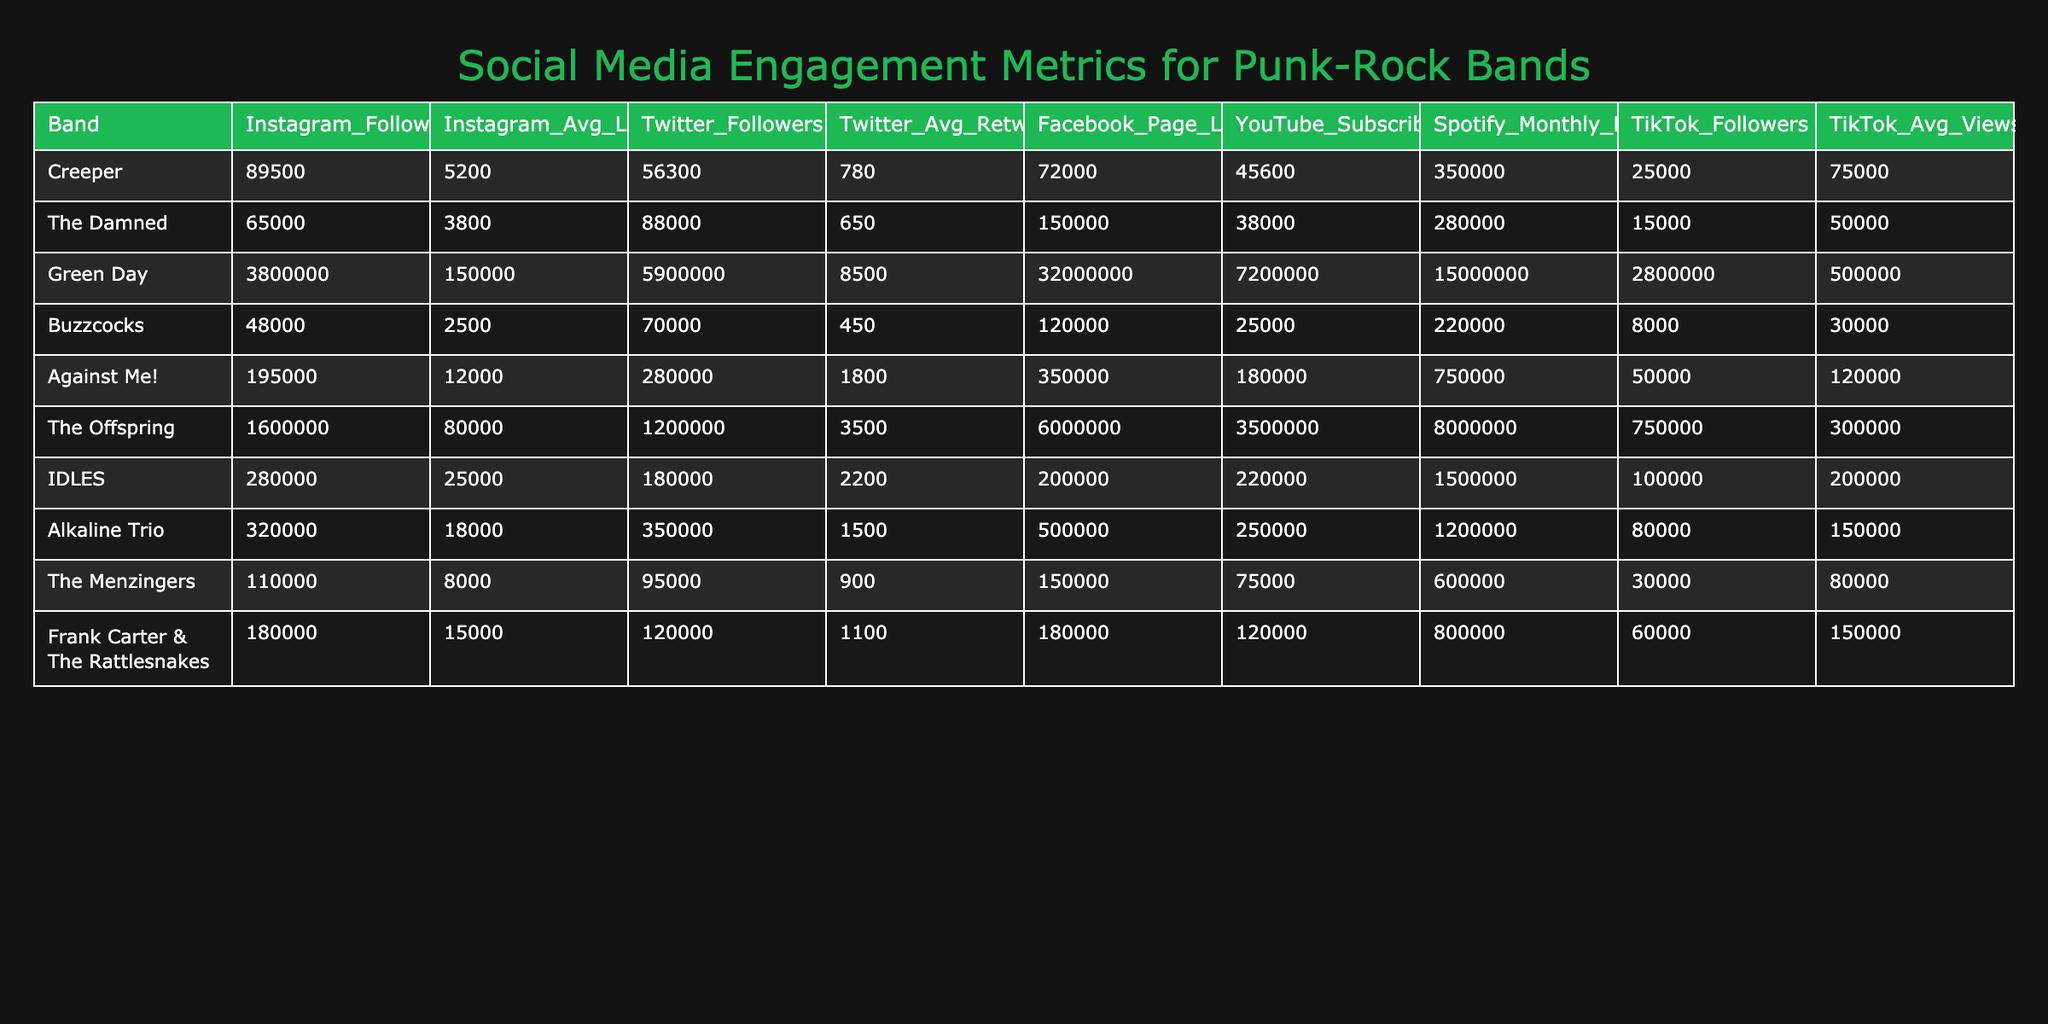What is the Instagram average likes for Creeper? The table lists 5 columns, and for Creeper, the column labeled "Instagram_Avg_Likes" shows the value of 5200.
Answer: 5200 Which band has the highest number of YouTube subscribers? The "YouTube_Subscribers" column is compared across all bands, and Green Day shows the highest value of 7200000.
Answer: Green Day What is the total number of Spotify monthly listeners for IDLES and Alkaline Trio combined? For IDLES, the value is 1500000 and for Alkaline Trio, it's 1200000. Adding them together gives 1500000 + 1200000 = 2700000.
Answer: 2700000 Does The Damned have more Instagram followers than Buzzcocks? The "Instagram_Followers" column shows The Damned has 65000 and Buzzcocks has 48000. Since 65000 is greater than 48000, the answer is yes.
Answer: Yes What is the average number of TikTok followers for all bands in the table? Summing the TikTok followers for all bands gives 25000 + 15000 + 2800000 + 8000 + 50000 + 750000 + 80000 + 60000 = 3651080. There are 10 bands, so the average is 3651080 / 10 = 365108.
Answer: 365108 Which band has the lowest average retweets on Twitter? Looking through the "Twitter_Avg_Retweets" column, Buzzcocks shows the lowest value at 450.
Answer: Buzzcocks How many more Facebook Page Likes does The Offspring have compared to Against Me!? The Offspring has 6000000 and Against Me! has 350000. The difference is 6000000 - 350000 = 5650000.
Answer: 5650000 Which band has a higher TikTok average views, Creeper or Frank Carter & The Rattlesnakes? Creeper has 75000 and Frank Carter & The Rattlesnakes has 150000. Since 150000 is greater than 75000, Frank Carter & The Rattlesnakes has higher TikTok average views.
Answer: Frank Carter & The Rattlesnakes What is the sum of Instagram followers for all bands listed? Adding up the values from the "Instagram_Followers" column (89500 + 65000 + 3800000 + 48000 + 195000 + 1600000 + 280000 + 320000 + 110000 + 180000) gives a total of 6001948.
Answer: 6001948 Do all bands listed have at least 50000 TikTok followers? Checking the "TikTok_Followers" column, both Buzzcocks and The Damned have values below 50000, so not all bands meet this criteria.
Answer: No 